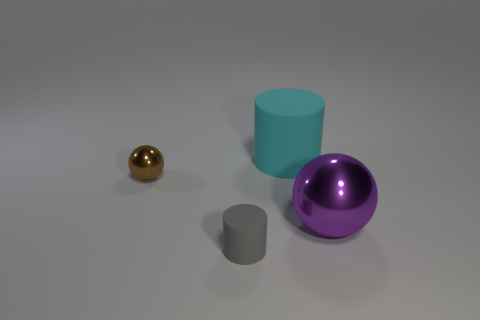Add 3 large cyan matte things. How many objects exist? 7 Add 1 big cyan cylinders. How many big cyan cylinders exist? 2 Subtract 0 green cylinders. How many objects are left? 4 Subtract all big brown metal objects. Subtract all large rubber cylinders. How many objects are left? 3 Add 2 brown metallic objects. How many brown metallic objects are left? 3 